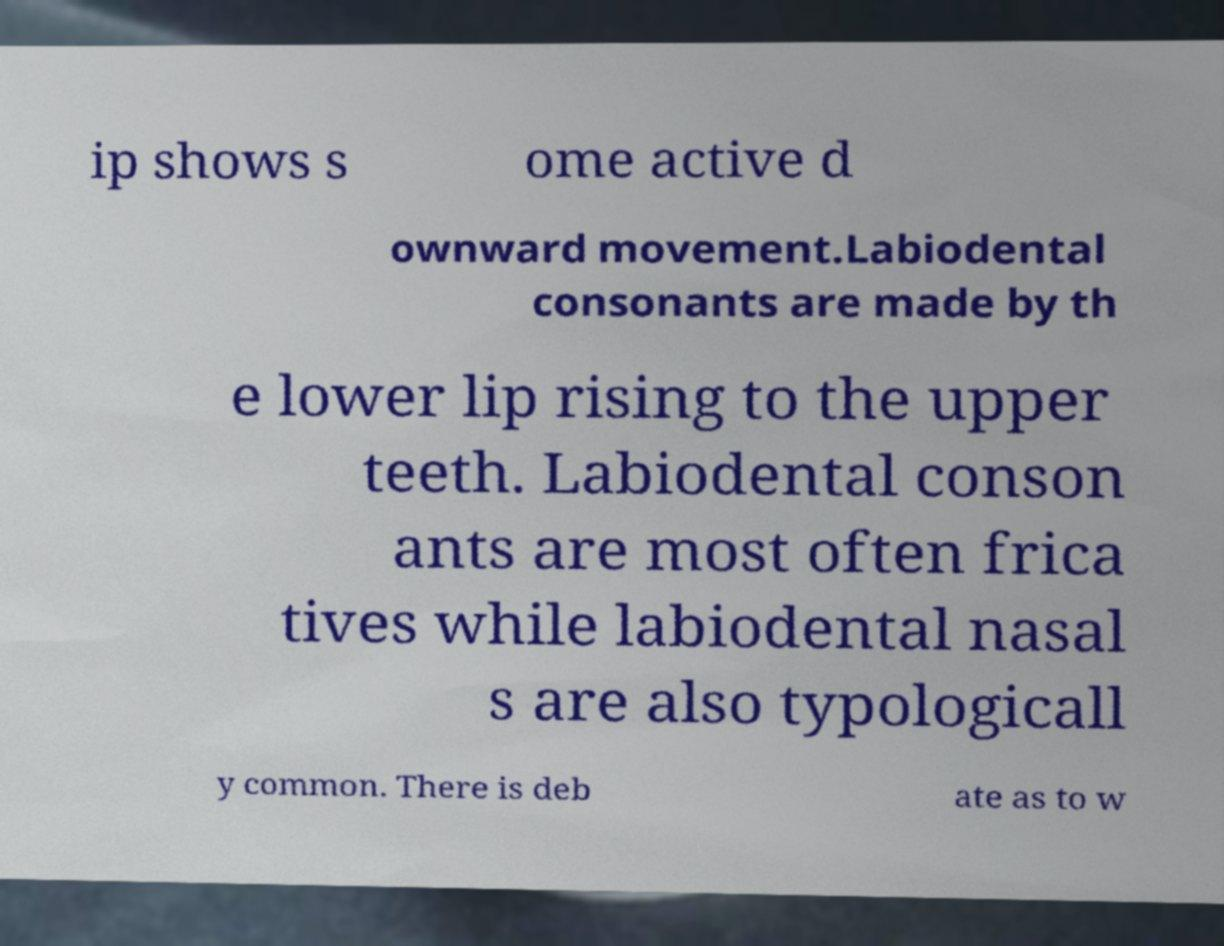Can you read and provide the text displayed in the image?This photo seems to have some interesting text. Can you extract and type it out for me? ip shows s ome active d ownward movement.Labiodental consonants are made by th e lower lip rising to the upper teeth. Labiodental conson ants are most often frica tives while labiodental nasal s are also typologicall y common. There is deb ate as to w 